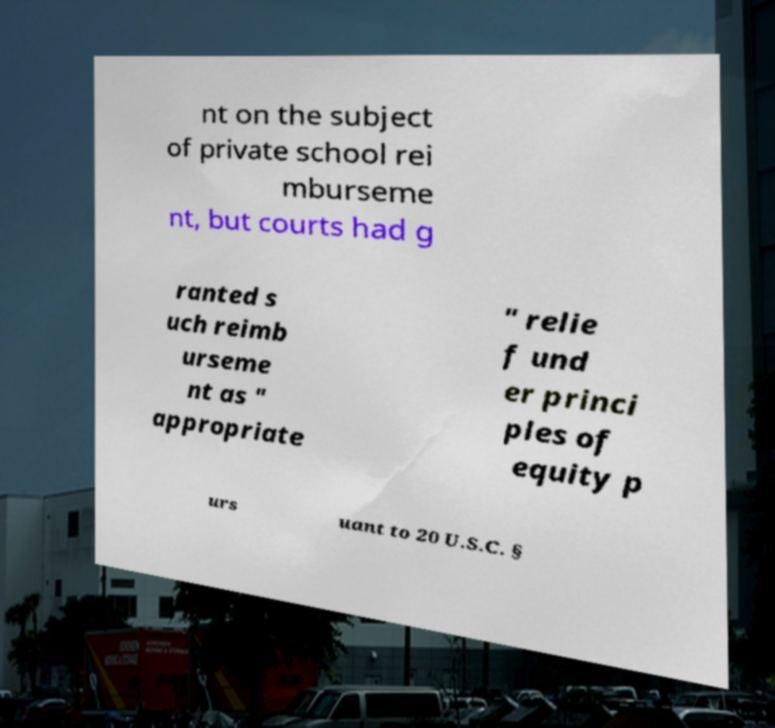I need the written content from this picture converted into text. Can you do that? nt on the subject of private school rei mburseme nt, but courts had g ranted s uch reimb urseme nt as " appropriate " relie f und er princi ples of equity p urs uant to 20 U.S.C. § 